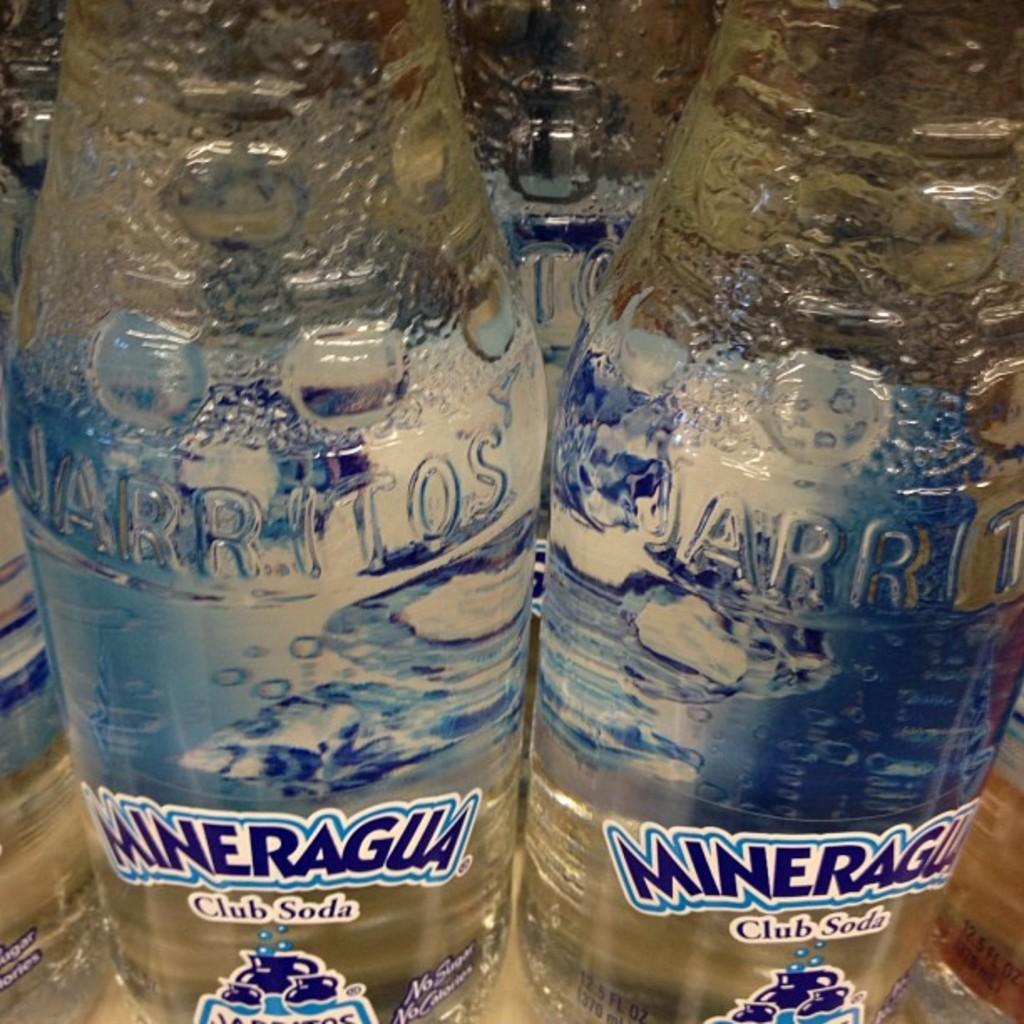What type of beverages are present in the image? There is a bunch of soda bottles in the image. Can you describe the arrangement of the soda bottles? The provided facts do not specify the arrangement of the soda bottles. Are the soda bottles of the same brand or flavor? The provided facts do not specify the brand or flavor of the soda bottles. What type of road can be seen in the image? There is no road present in the image; it only contains a bunch of soda bottles. How many zebras are visible in the image? There are no zebras present in the image; it only contains a bunch of soda bottles. 